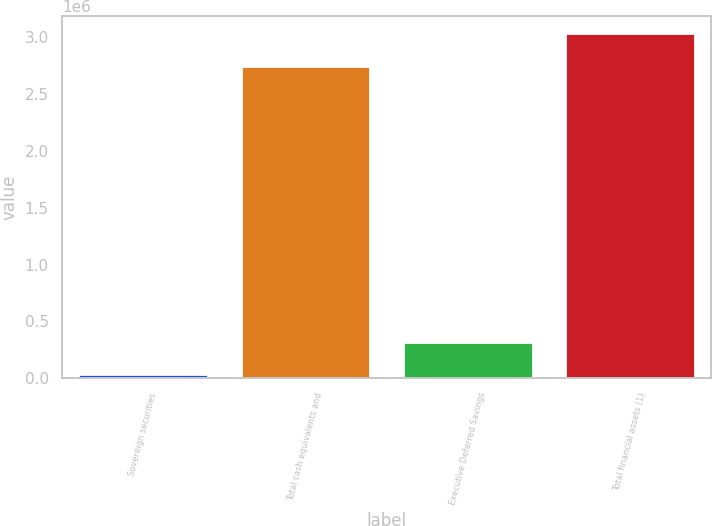Convert chart to OTSL. <chart><loc_0><loc_0><loc_500><loc_500><bar_chart><fcel>Sovereign securities<fcel>Total cash equivalents and<fcel>Executive Deferred Savings<fcel>Total financial assets (1)<nl><fcel>33805<fcel>2.75001e+06<fcel>319473<fcel>3.03568e+06<nl></chart> 